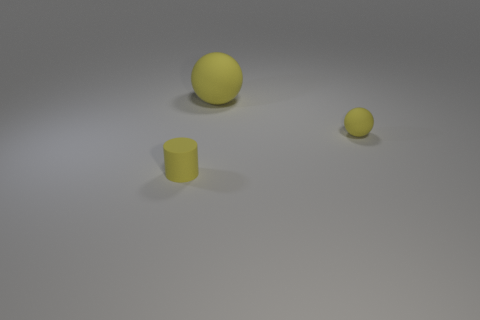Subtract all yellow spheres. How many were subtracted if there are1yellow spheres left? 1 Subtract 0 gray cylinders. How many objects are left? 3 Subtract all cylinders. How many objects are left? 2 Subtract 2 spheres. How many spheres are left? 0 Subtract all green balls. Subtract all purple blocks. How many balls are left? 2 Subtract all green cylinders. How many cyan spheres are left? 0 Subtract all tiny red metal spheres. Subtract all yellow balls. How many objects are left? 1 Add 1 tiny yellow matte objects. How many tiny yellow matte objects are left? 3 Add 1 yellow things. How many yellow things exist? 4 Add 2 yellow matte things. How many objects exist? 5 